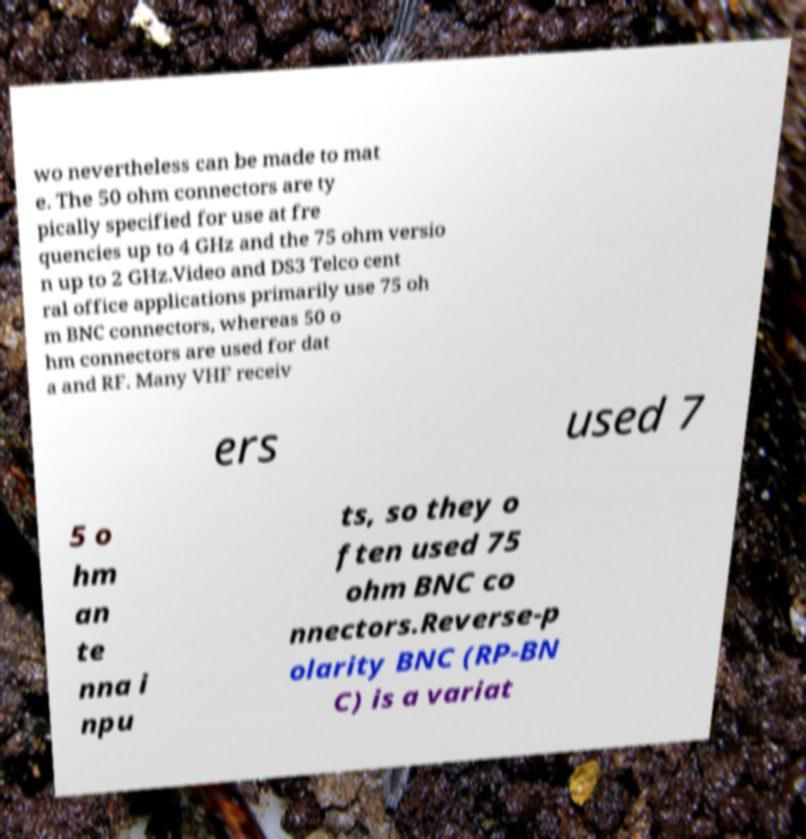Can you read and provide the text displayed in the image?This photo seems to have some interesting text. Can you extract and type it out for me? wo nevertheless can be made to mat e. The 50 ohm connectors are ty pically specified for use at fre quencies up to 4 GHz and the 75 ohm versio n up to 2 GHz.Video and DS3 Telco cent ral office applications primarily use 75 oh m BNC connectors, whereas 50 o hm connectors are used for dat a and RF. Many VHF receiv ers used 7 5 o hm an te nna i npu ts, so they o ften used 75 ohm BNC co nnectors.Reverse-p olarity BNC (RP-BN C) is a variat 